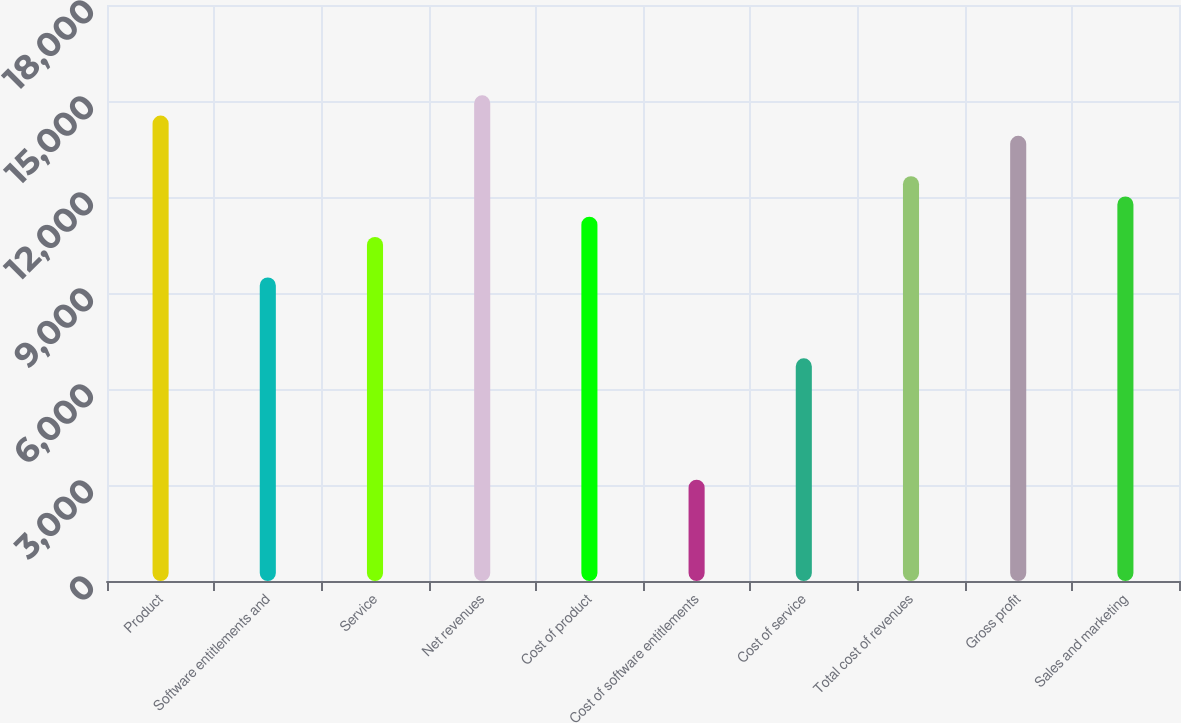<chart> <loc_0><loc_0><loc_500><loc_500><bar_chart><fcel>Product<fcel>Software entitlements and<fcel>Service<fcel>Net revenues<fcel>Cost of product<fcel>Cost of software entitlements<fcel>Cost of service<fcel>Total cost of revenues<fcel>Gross profit<fcel>Sales and marketing<nl><fcel>14545.4<fcel>9486.78<fcel>10751.4<fcel>15177.8<fcel>11383.8<fcel>3163.48<fcel>6957.46<fcel>12648.4<fcel>13913.1<fcel>12016.1<nl></chart> 